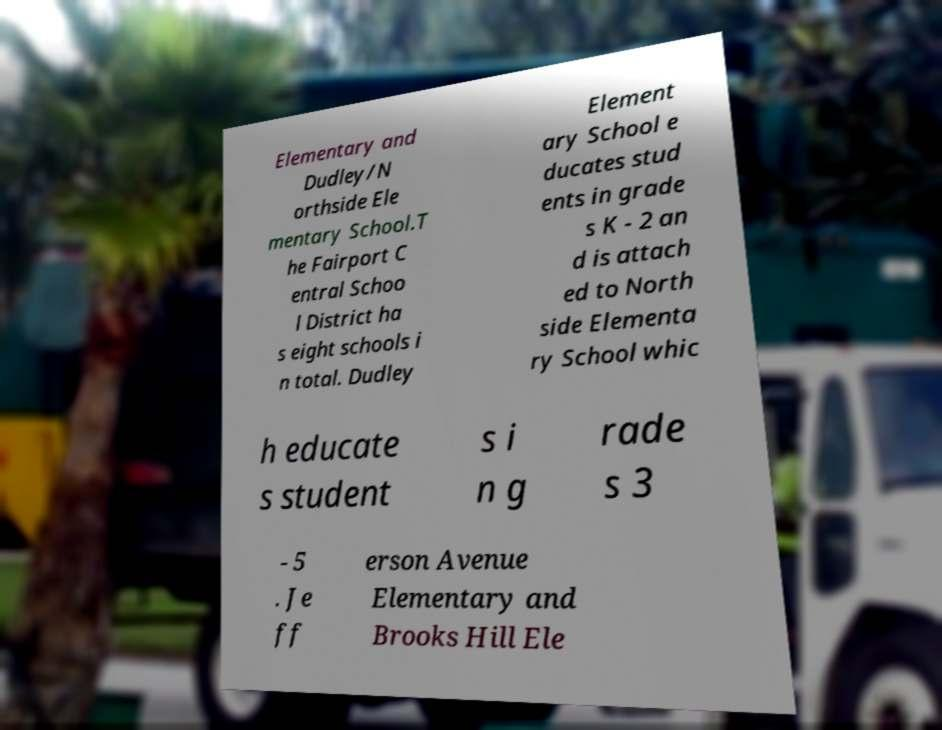Can you accurately transcribe the text from the provided image for me? Elementary and Dudley/N orthside Ele mentary School.T he Fairport C entral Schoo l District ha s eight schools i n total. Dudley Element ary School e ducates stud ents in grade s K - 2 an d is attach ed to North side Elementa ry School whic h educate s student s i n g rade s 3 - 5 . Je ff erson Avenue Elementary and Brooks Hill Ele 